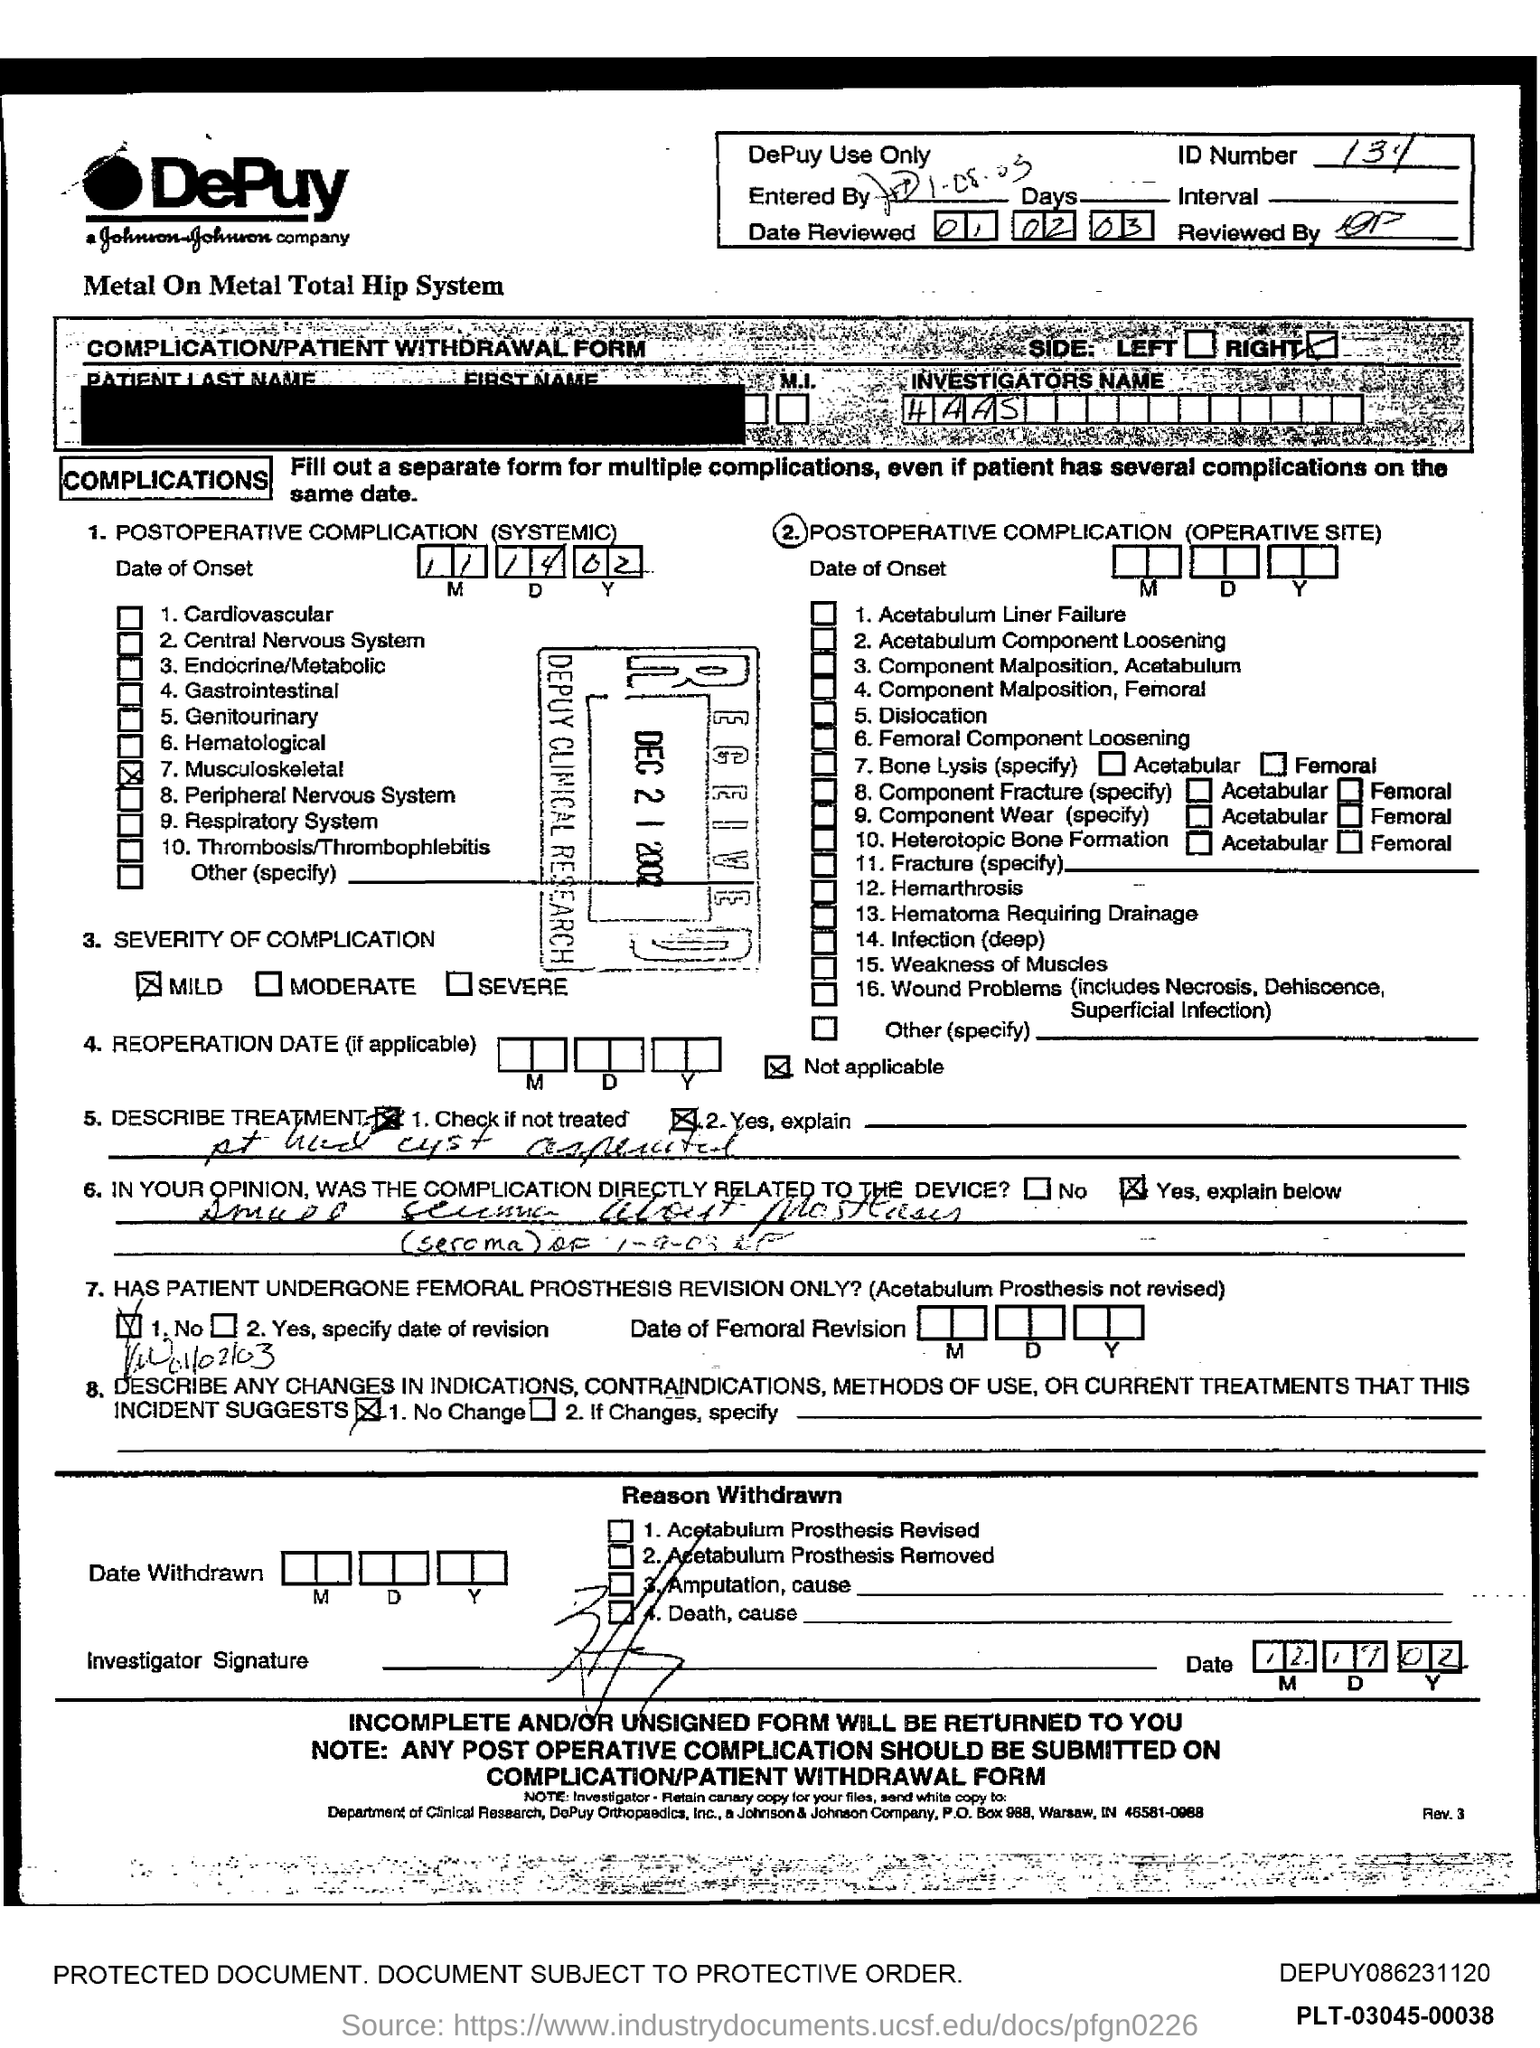List a handful of essential elements in this visual. The name of the investigator is Haas. 